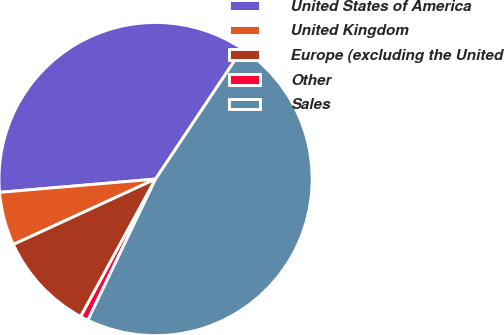Convert chart. <chart><loc_0><loc_0><loc_500><loc_500><pie_chart><fcel>United States of America<fcel>United Kingdom<fcel>Europe (excluding the United<fcel>Other<fcel>Sales<nl><fcel>35.72%<fcel>5.51%<fcel>10.2%<fcel>0.82%<fcel>47.75%<nl></chart> 